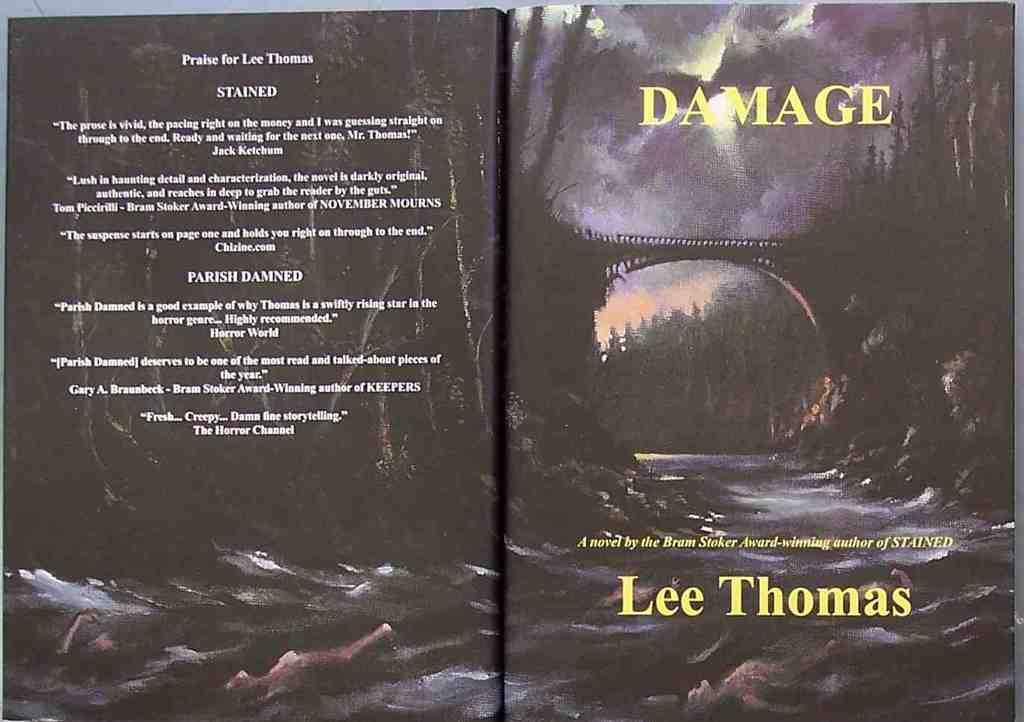<image>
Render a clear and concise summary of the photo. A book titled "Damage" by Lee Thomas who is award winning author of "Stained"/ 